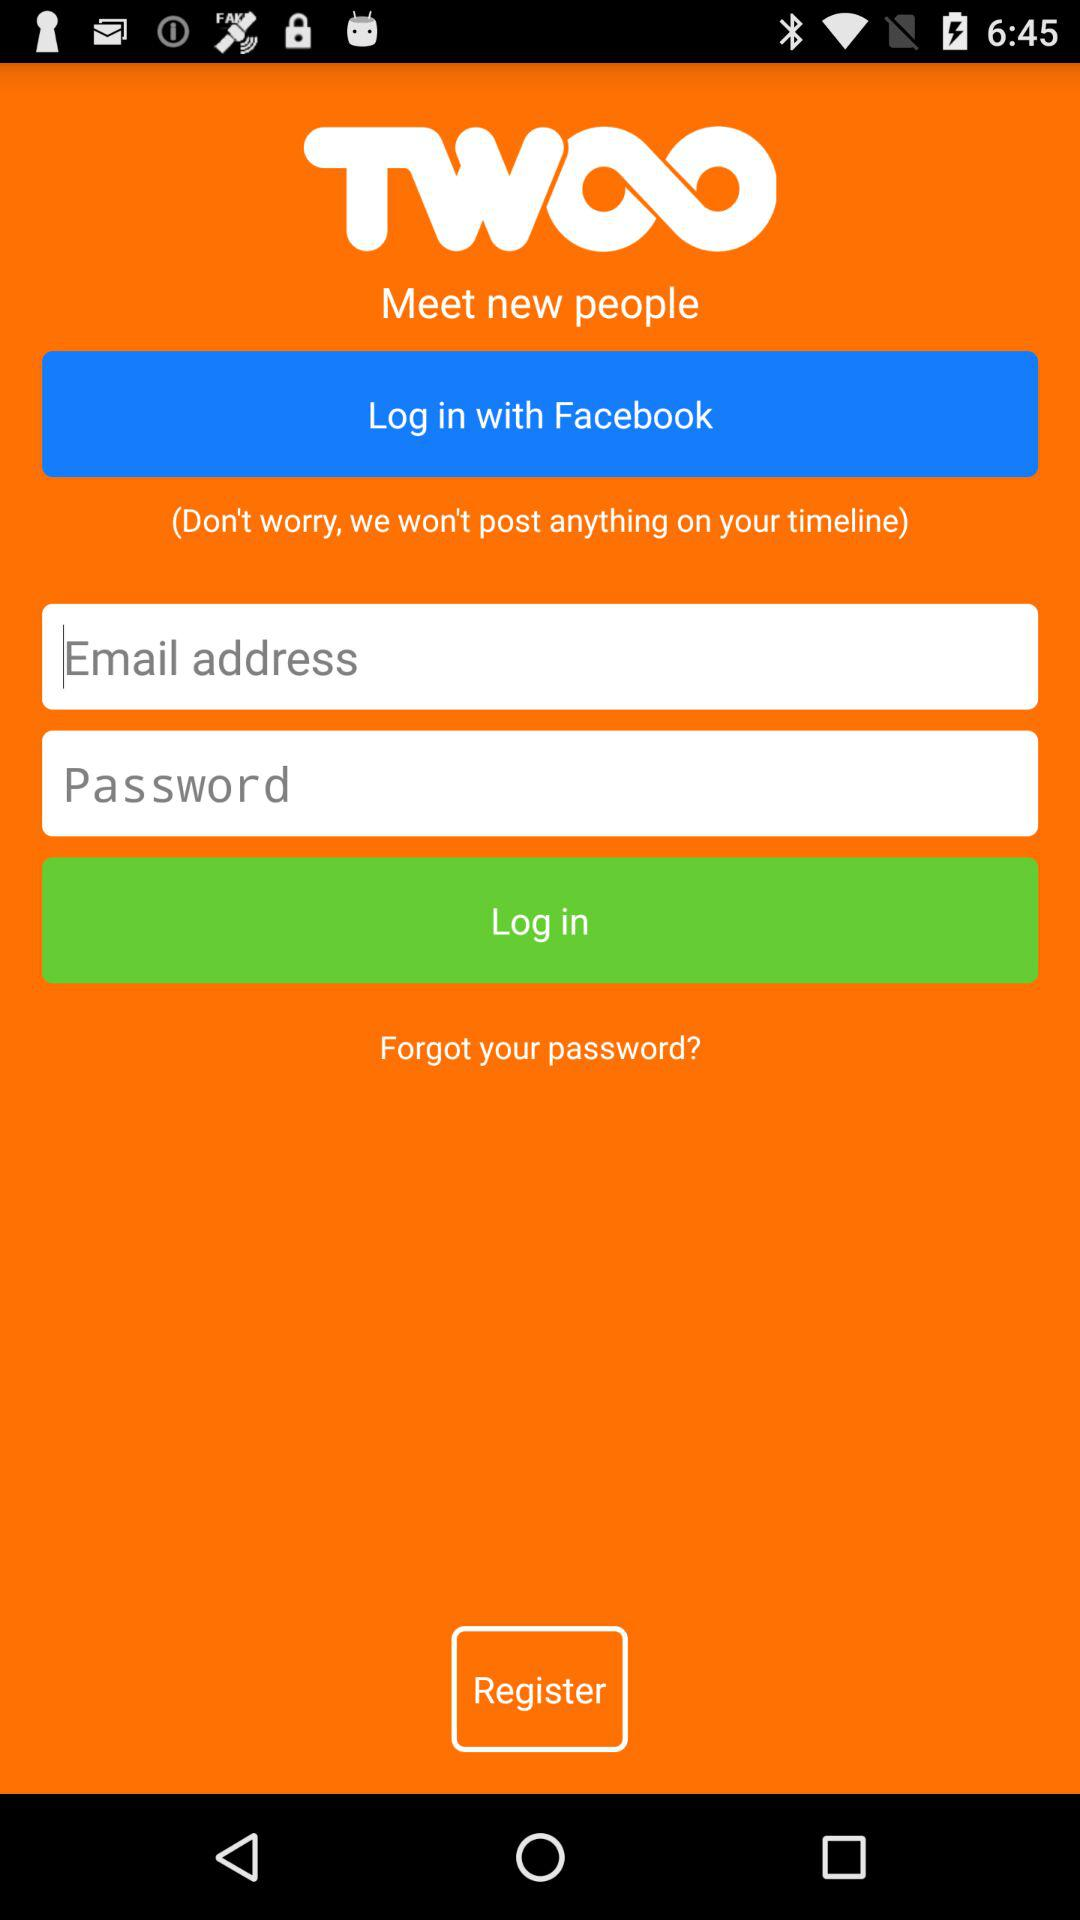How many login options are there?
Answer the question using a single word or phrase. 2 